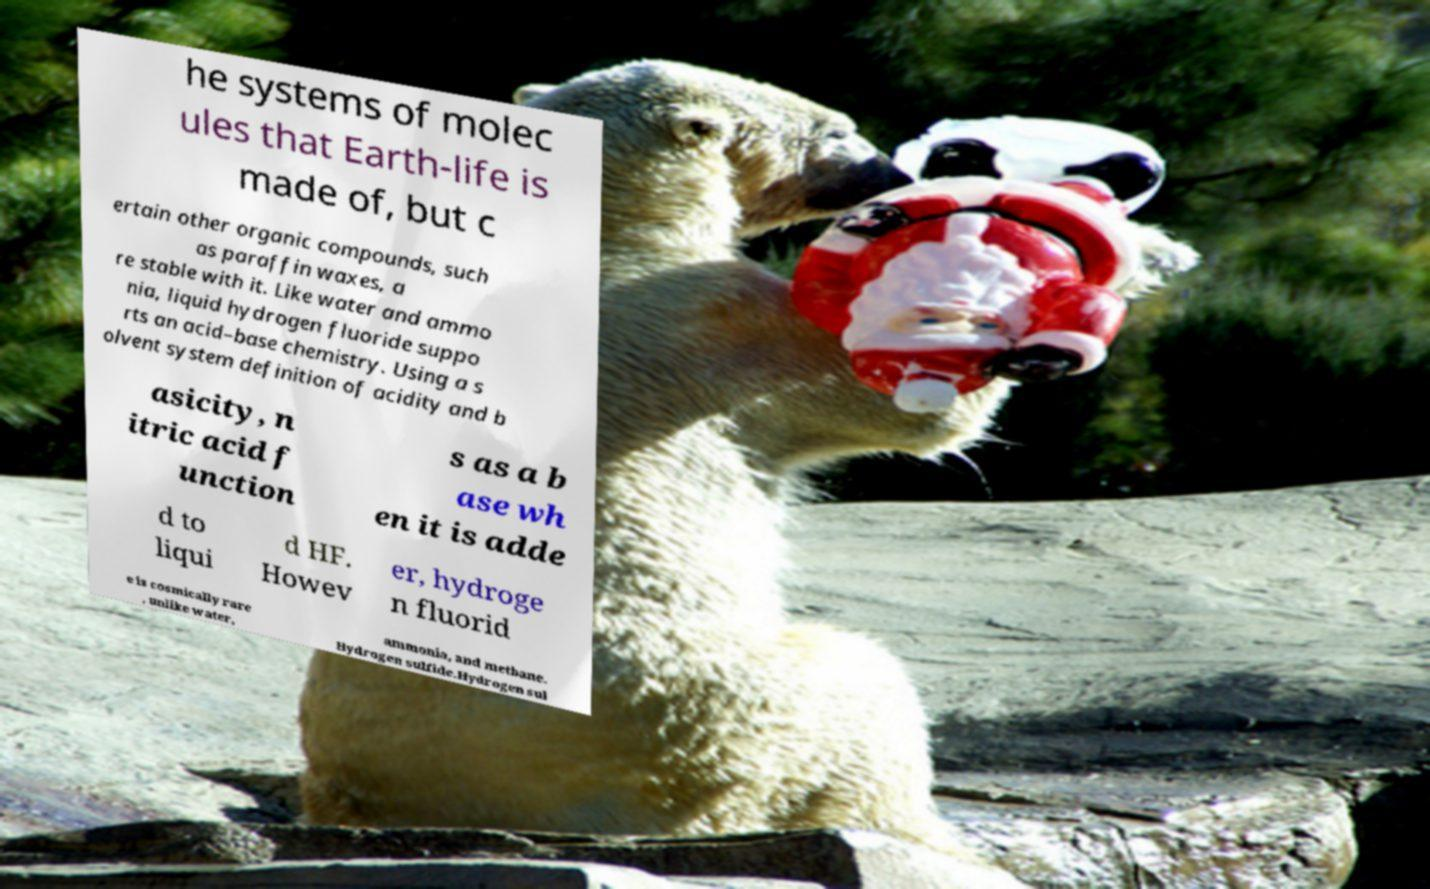Could you assist in decoding the text presented in this image and type it out clearly? he systems of molec ules that Earth-life is made of, but c ertain other organic compounds, such as paraffin waxes, a re stable with it. Like water and ammo nia, liquid hydrogen fluoride suppo rts an acid–base chemistry. Using a s olvent system definition of acidity and b asicity, n itric acid f unction s as a b ase wh en it is adde d to liqui d HF. Howev er, hydroge n fluorid e is cosmically rare , unlike water, ammonia, and methane. Hydrogen sulfide.Hydrogen sul 